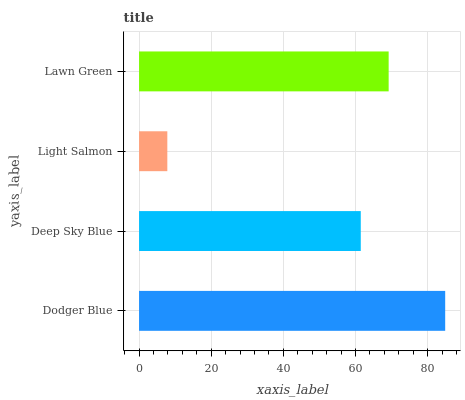Is Light Salmon the minimum?
Answer yes or no. Yes. Is Dodger Blue the maximum?
Answer yes or no. Yes. Is Deep Sky Blue the minimum?
Answer yes or no. No. Is Deep Sky Blue the maximum?
Answer yes or no. No. Is Dodger Blue greater than Deep Sky Blue?
Answer yes or no. Yes. Is Deep Sky Blue less than Dodger Blue?
Answer yes or no. Yes. Is Deep Sky Blue greater than Dodger Blue?
Answer yes or no. No. Is Dodger Blue less than Deep Sky Blue?
Answer yes or no. No. Is Lawn Green the high median?
Answer yes or no. Yes. Is Deep Sky Blue the low median?
Answer yes or no. Yes. Is Deep Sky Blue the high median?
Answer yes or no. No. Is Dodger Blue the low median?
Answer yes or no. No. 